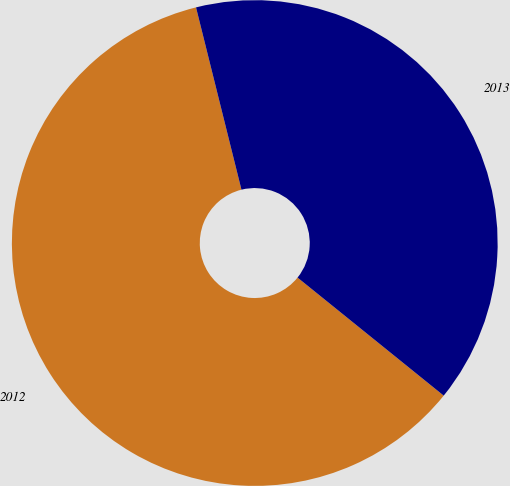Convert chart. <chart><loc_0><loc_0><loc_500><loc_500><pie_chart><fcel>2012<fcel>2013<nl><fcel>60.3%<fcel>39.7%<nl></chart> 